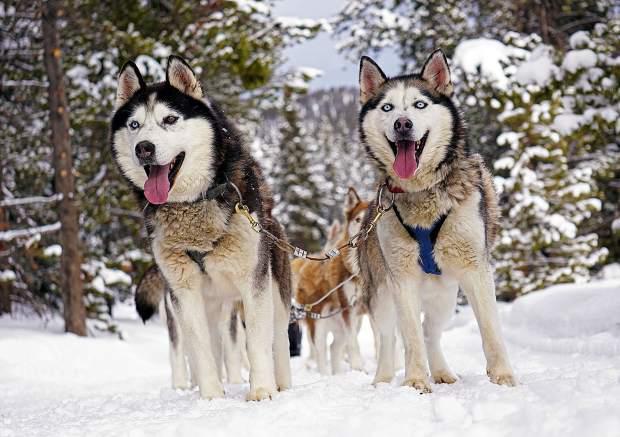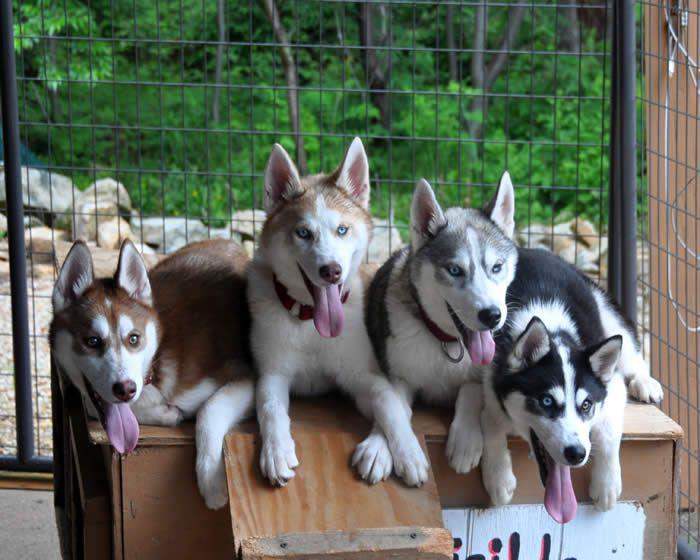The first image is the image on the left, the second image is the image on the right. Evaluate the accuracy of this statement regarding the images: "The left image shows a sled dog team heading forward over snow, and the right image shows dogs hitched to a forward-facing wheeled vehicle on a path bare of snow.". Is it true? Answer yes or no. No. The first image is the image on the left, the second image is the image on the right. Analyze the images presented: Is the assertion "All of the dogs are moving forward." valid? Answer yes or no. No. 